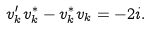<formula> <loc_0><loc_0><loc_500><loc_500>v _ { k } ^ { \prime } v _ { k } ^ { * } - v _ { k } ^ { * } v _ { k } = - 2 i .</formula> 